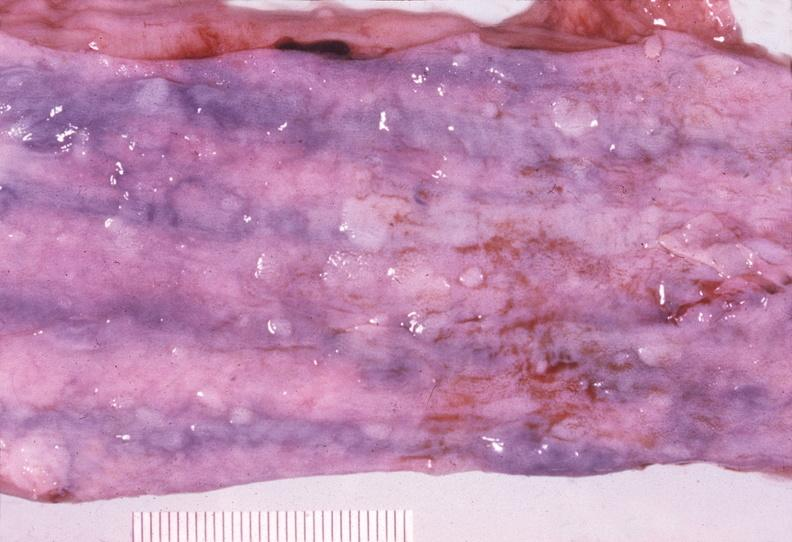s gastrointestinal present?
Answer the question using a single word or phrase. Yes 